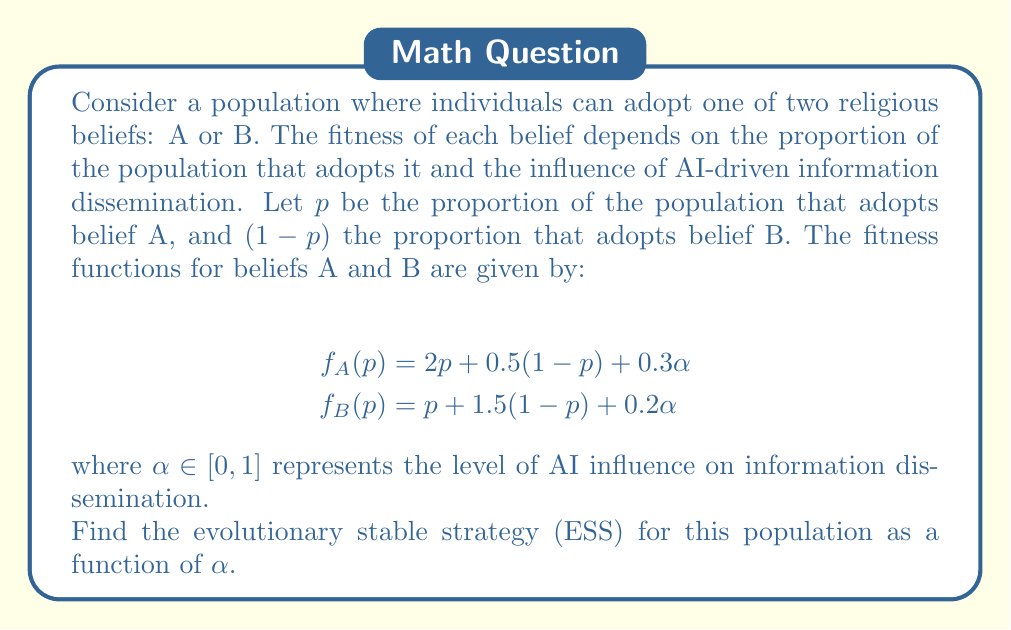Help me with this question. To solve this problem, we need to follow these steps:

1) An ESS is a strategy that, if adopted by a population, cannot be invaded by any alternative strategy. In our case, we need to find the value of $p$ where the fitness of both beliefs is equal.

2) Set the fitness functions equal to each other:

   $$f_A(p) = f_B(p)$$
   $$2p + 0.5(1-p) + 0.3\alpha = p + 1.5(1-p) + 0.2\alpha$$

3) Simplify the equation:

   $$2p + 0.5 - 0.5p + 0.3\alpha = p + 1.5 - 1.5p + 0.2\alpha$$
   $$1.5p + 0.5 + 0.3\alpha = -0.5p + 1.5 + 0.2\alpha$$

4) Combine like terms:

   $$2p - 1 = 0.1\alpha$$

5) Solve for $p$:

   $$p = \frac{1 + 0.1\alpha}{2} = 0.5 + 0.05\alpha$$

6) This gives us the equilibrium point. To confirm it's an ESS, we need to check if it's stable. The strategy is stable if:

   $$f_A(p) > f_B(p)$$ when $p < 0.5 + 0.05\alpha$, and
   $$f_A(p) < f_B(p)$$ when $p > 0.5 + 0.05\alpha$

7) We can verify this by checking the slopes of the fitness functions:

   $$\frac{d}{dp}f_A(p) = 1.5$$
   $$\frac{d}{dp}f_B(p) = -0.5$$

   Since the slope of $f_A$ is greater than the slope of $f_B$, the equilibrium point is indeed stable.

Therefore, the ESS is $p = 0.5 + 0.05\alpha$, which represents the proportion of the population that should adopt belief A to achieve evolutionary stability.
Answer: The evolutionary stable strategy (ESS) for this population is $p = 0.5 + 0.05\alpha$, where $p$ is the proportion of the population that adopts belief A, and $\alpha$ is the level of AI influence on information dissemination. 